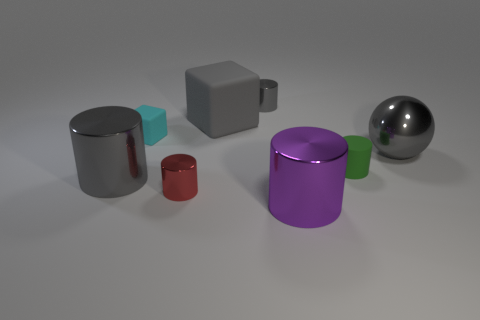Is there another cylinder that has the same color as the matte cylinder?
Provide a short and direct response. No. The ball that is the same size as the purple metal cylinder is what color?
Offer a very short reply. Gray. There is a tiny object behind the matte object that is on the left side of the gray cube on the left side of the large ball; what is its material?
Keep it short and to the point. Metal. Is the color of the sphere the same as the small matte thing behind the rubber cylinder?
Offer a terse response. No. How many things are big gray objects that are to the right of the large gray cylinder or big shiny things behind the big purple shiny thing?
Offer a terse response. 3. What is the shape of the small matte thing that is to the left of the gray metal cylinder behind the large sphere?
Keep it short and to the point. Cube. Are there any other gray cylinders that have the same material as the tiny gray cylinder?
Give a very brief answer. Yes. What color is the other big object that is the same shape as the purple object?
Your response must be concise. Gray. Are there fewer green matte objects behind the tiny cyan rubber block than gray rubber things that are in front of the large gray sphere?
Keep it short and to the point. No. What number of other things are there of the same shape as the small red shiny object?
Your answer should be very brief. 4. 